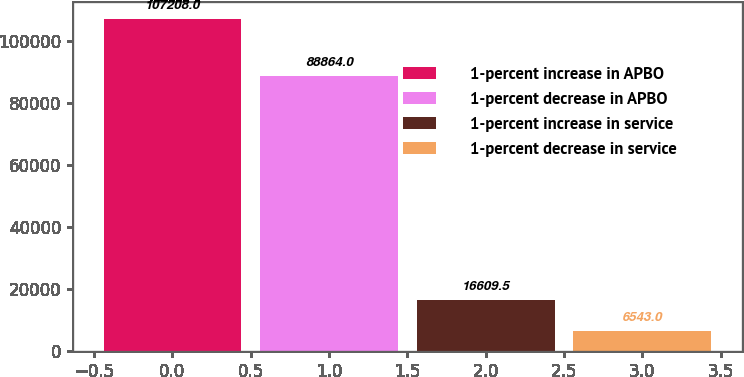<chart> <loc_0><loc_0><loc_500><loc_500><bar_chart><fcel>1-percent increase in APBO<fcel>1-percent decrease in APBO<fcel>1-percent increase in service<fcel>1-percent decrease in service<nl><fcel>107208<fcel>88864<fcel>16609.5<fcel>6543<nl></chart> 